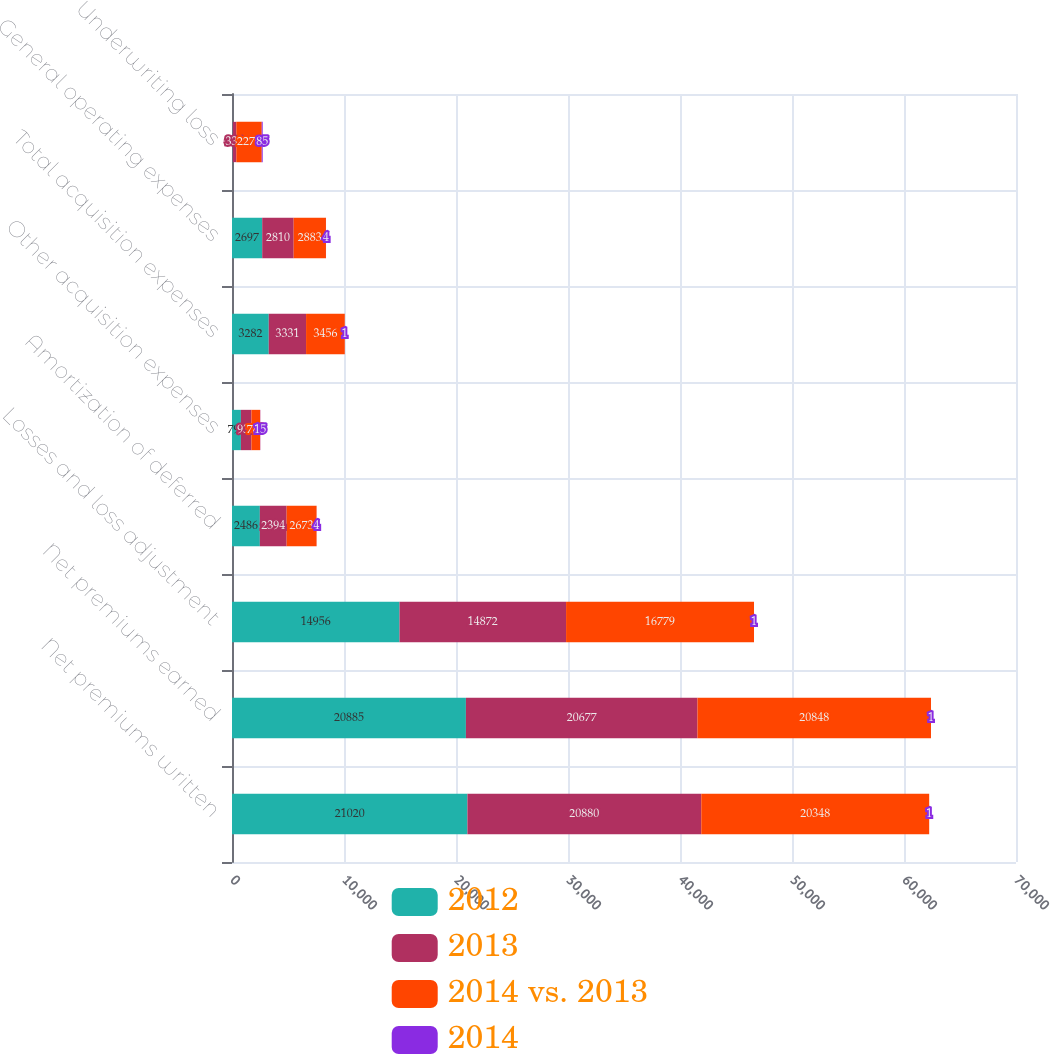Convert chart to OTSL. <chart><loc_0><loc_0><loc_500><loc_500><stacked_bar_chart><ecel><fcel>Net premiums written<fcel>Net premiums earned<fcel>Losses and loss adjustment<fcel>Amortization of deferred<fcel>Other acquisition expenses<fcel>Total acquisition expenses<fcel>General operating expenses<fcel>Underwriting loss<nl><fcel>2012<fcel>21020<fcel>20885<fcel>14956<fcel>2486<fcel>796<fcel>3282<fcel>2697<fcel>50<nl><fcel>2013<fcel>20880<fcel>20677<fcel>14872<fcel>2394<fcel>937<fcel>3331<fcel>2810<fcel>336<nl><fcel>2014 vs. 2013<fcel>20348<fcel>20848<fcel>16779<fcel>2673<fcel>783<fcel>3456<fcel>2883<fcel>2270<nl><fcel>2014<fcel>1<fcel>1<fcel>1<fcel>4<fcel>15<fcel>1<fcel>4<fcel>85<nl></chart> 